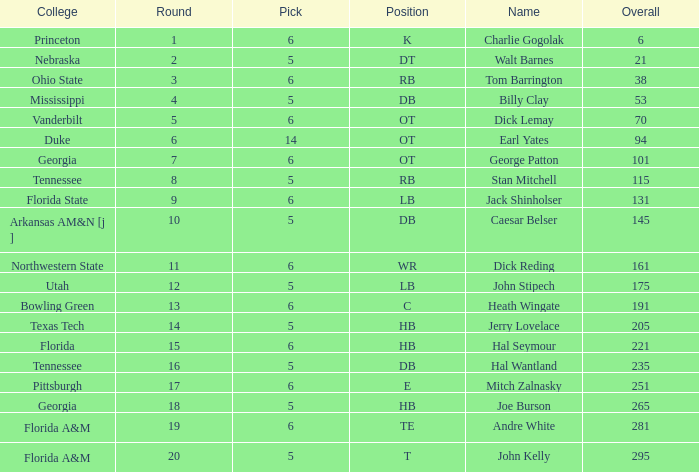What is the sum of Overall, when Pick is greater than 5, when Round is less than 11, and when Name is "Tom Barrington"? 38.0. 